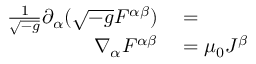<formula> <loc_0><loc_0><loc_500><loc_500>\begin{array} { r l } { { \frac { 1 } { \sqrt { - g } } } \partial _ { \alpha } ( { \sqrt { - g } } F ^ { \alpha \beta } ) } & = } \\ { \nabla _ { \alpha } F ^ { \alpha \beta } } & = \mu _ { 0 } J ^ { \beta } } \end{array}</formula> 